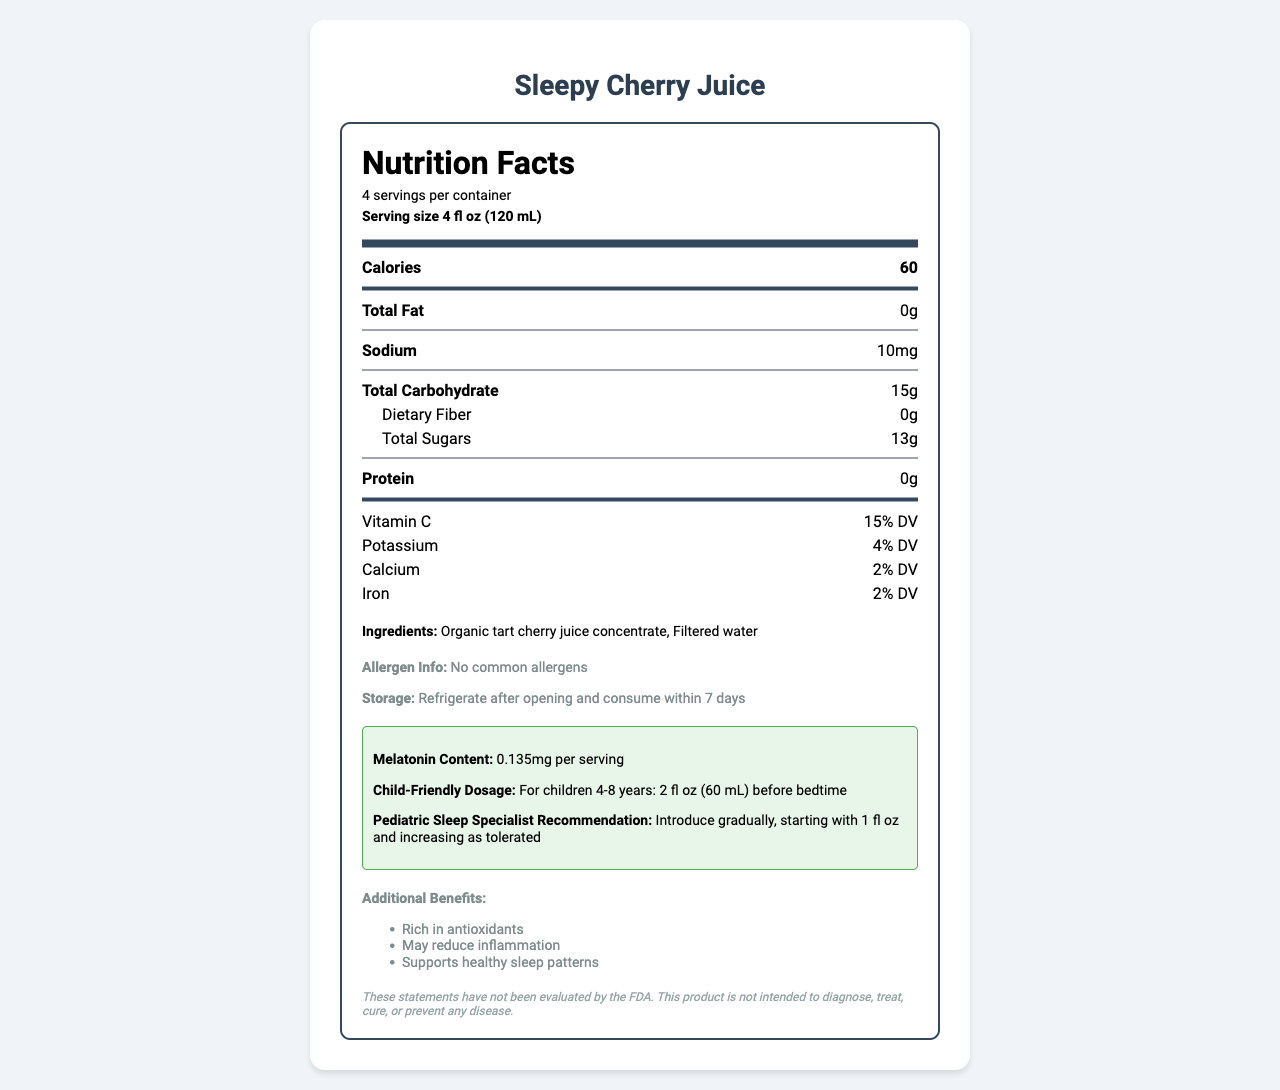what is the serving size of the Sleepy Cherry Juice? The label indicates the serving size is 4 fl oz (120 mL).
Answer: 4 fl oz (120 mL) how many calories are in one serving of Sleepy Cherry Juice? The label mentions that each serving contains 60 calories.
Answer: 60 what is the melatonin content per serving? The label specifies that each serving contains 0.135mg of melatonin.
Answer: 0.135mg how much sodium is in one serving of the juice? According to the label, one serving has 10mg of sodium.
Answer: 10mg what are the main ingredients in Sleepy Cherry Juice? The ingredients listed on the label are organic tart cherry juice concentrate and filtered water.
Answer: Organic tart cherry juice concentrate, Filtered water how many servings are there in one container of Sleepy Cherry Juice? The label states that there are 4 servings per container.
Answer: 4 according to the pediatric sleep specialist's recommendation, how should the juice be introduced to children? The recommendation is to introduce the juice gradually, starting with 1 fl oz and increasing as tolerated.
Answer: Introduce gradually, starting with 1 fl oz and increasing as tolerated what is the child-friendly dosage for children aged 4-8 years? The label advises a dosage of 2 fl oz (60 mL) before bedtime for children aged 4-8 years.
Answer: 2 fl oz (60 mL) before bedtime does Sleepy Cherry Juice contain any common allergens? The label indicates that there are no common allergens in the product.
Answer: No what additional benefits are mentioned for Sleepy Cherry Juice? The additional benefits listed on the label include being rich in antioxidants, possibly reducing inflammation, and supporting healthy sleep patterns.
Answer: Rich in antioxidants, May reduce inflammation, Supports healthy sleep patterns who is the manufacturer of Sleepy Cherry Juice? The label lists the manufacturer as SweetDreams Nutrition Co.
Answer: SweetDreams Nutrition Co. how long can the Sleepy Cherry Juice be stored after opening? The label states that the juice should be refrigerated after opening and consumed within 7 days.
Answer: 7 days summarize the key information provided in the Nutrition Facts section of the Sleepy Cherry Juice label. The label breaks down the nutritional content per serving size, including calories, fats, sodium, carbohydrates, and essential vitamins and minerals. It also includes information about the melatonin content, recommended dosage for children, and the primary ingredients used in the juice.
Answer: The Nutrition Facts section provides details on the serving size, calories, fat, sodium, total carbohydrate, dietary fiber, total sugars, protein, and essential vitamins and minerals in Sleepy Cherry Juice. It also highlights the melatonin content, child-friendly dosage, pediatric sleep specialist recommendations, and key ingredients. which of the following is a benefit of Sleepy Cherry Juice? A. Contains caffeine B. Supports healthy sleep patterns C. High in unhealthy fats D. Low in calories The label mentions that Sleepy Cherry Juice supports healthy sleep patterns.
Answer: B which nutrient is not listed on the Sleepy Cherry Juice label? A. Iron B. Vitamin D C. Potassium D. Vitamin C Vitamin D is not mentioned on the label, while Iron, Potassium, and Vitamin C are.
Answer: B does the Sleepy Cherry Juice have any dietary fiber? The label specifies that the juice has 0g of dietary fiber.
Answer: No what is the vitamin C daily value percentage in one serving? According to the label, one serving provides 15% of the daily value for Vitamin C.
Answer: 15% DV can we determine if the Sleepy Cherry Juice is safe according to FDA standards? The label includes a disclaimer stating that these statements have not been evaluated by the FDA. Therefore, it's not possible to determine FDA compliance based on the label alone.
Answer: Not enough information 